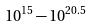Convert formula to latex. <formula><loc_0><loc_0><loc_500><loc_500>1 0 ^ { 1 5 } - 1 0 ^ { 2 0 . 5 }</formula> 